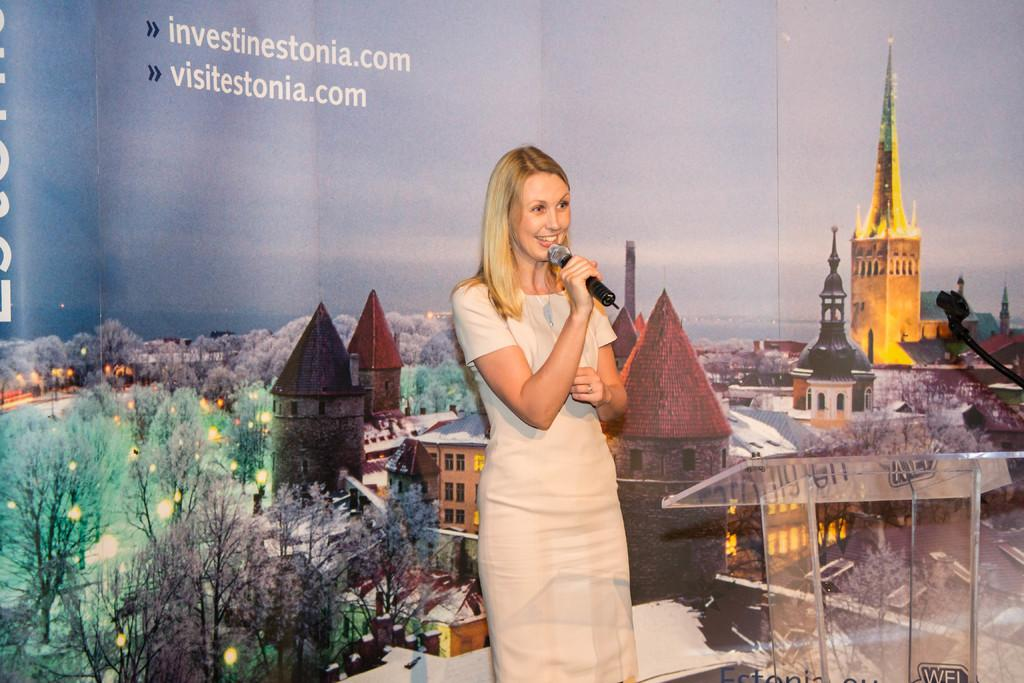Who is the main subject in the image? There is a woman in the image. What is the woman doing in the image? The woman is standing and holding a microphone. What can be seen on the right side of the image? There is a glass table on the right side of the image. What is present at the back of the image? There is a banner at the back of the image. Can you see a spoon being used by the ghost in the image? There is no ghost or spoon present in the image. 